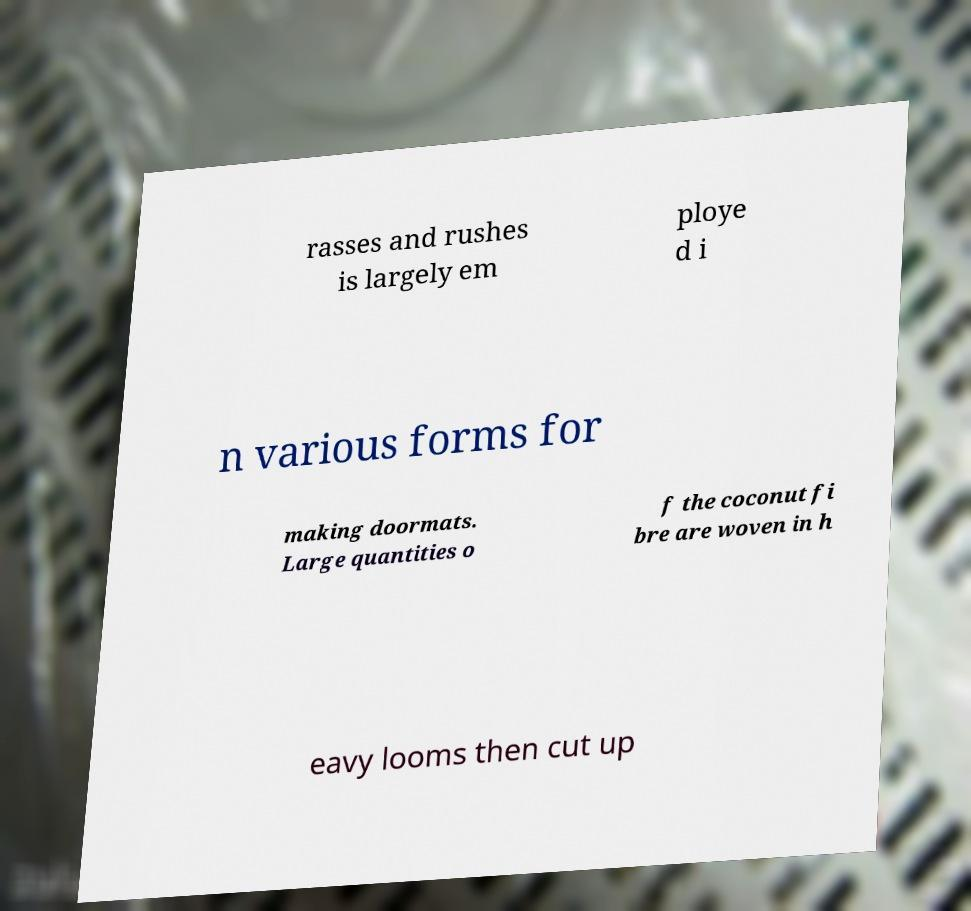Can you accurately transcribe the text from the provided image for me? rasses and rushes is largely em ploye d i n various forms for making doormats. Large quantities o f the coconut fi bre are woven in h eavy looms then cut up 